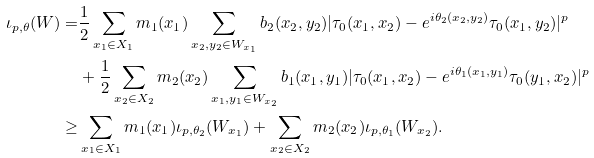<formula> <loc_0><loc_0><loc_500><loc_500>\iota _ { p , \theta } ( W ) = & \frac { 1 } { 2 } \sum _ { x _ { 1 } \in X _ { 1 } } m _ { 1 } ( x _ { 1 } ) \sum _ { x _ { 2 } , y _ { 2 } \in W _ { x _ { 1 } } } b _ { 2 } ( x _ { 2 } , y _ { 2 } ) | \tau _ { 0 } ( x _ { 1 } , x _ { 2 } ) - e ^ { i \theta _ { 2 } ( x _ { 2 } , y _ { 2 } ) } \tau _ { 0 } ( x _ { 1 } , y _ { 2 } ) | ^ { p } \\ & + \frac { 1 } { 2 } \sum _ { x _ { 2 } \in X _ { 2 } } m _ { 2 } ( x _ { 2 } ) \sum _ { x _ { 1 } , y _ { 1 } \in W _ { x _ { 2 } } } b _ { 1 } ( x _ { 1 } , y _ { 1 } ) | \tau _ { 0 } ( x _ { 1 } , x _ { 2 } ) - e ^ { i \theta _ { 1 } ( x _ { 1 } , y _ { 1 } ) } \tau _ { 0 } ( y _ { 1 } , x _ { 2 } ) | ^ { p } \\ \geq & \sum _ { x _ { 1 } \in X _ { 1 } } m _ { 1 } ( x _ { 1 } ) \iota _ { p , \theta _ { 2 } } ( W _ { x _ { 1 } } ) + \sum _ { x _ { 2 } \in X _ { 2 } } m _ { 2 } ( x _ { 2 } ) \iota _ { p , \theta _ { 1 } } ( W _ { x _ { 2 } } ) .</formula> 